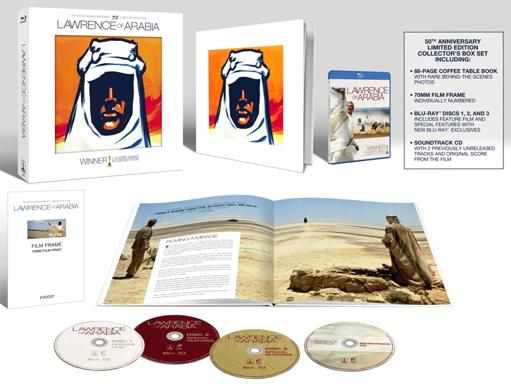Can you tell me more about the special features included in the anniversary set? The 50th Anniversary Collector's Box Set of 'Lawrence of Arabia' includes several special features across the Blu-ray discs. These features provide an in-depth look at the making of the film, including director's commentary, documentaries on the film's historical context, and interviews with film scholars and cast members. The set also contains a documentary specifically about the restoration process of the film for its Blu-ray release. 